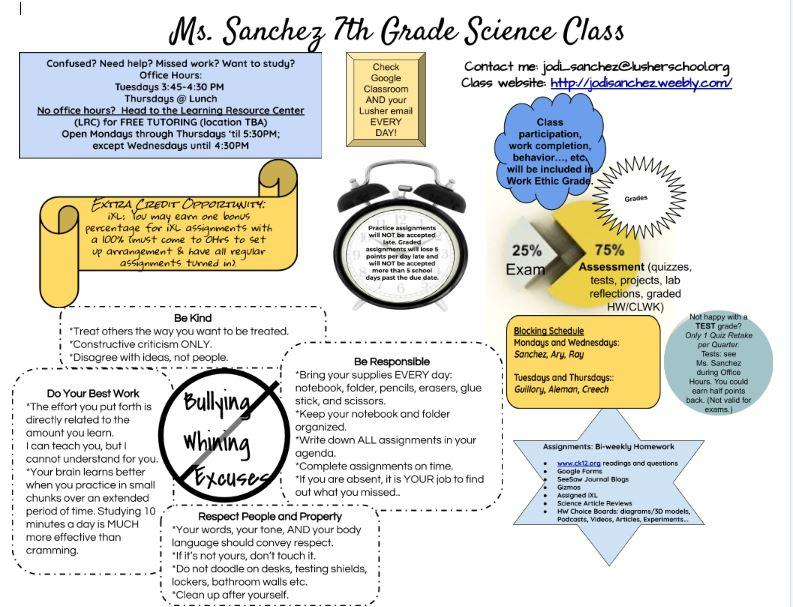Specify some key components in this picture. It is not appropriate to engage in bullying, whining, or making excuses during science class. 